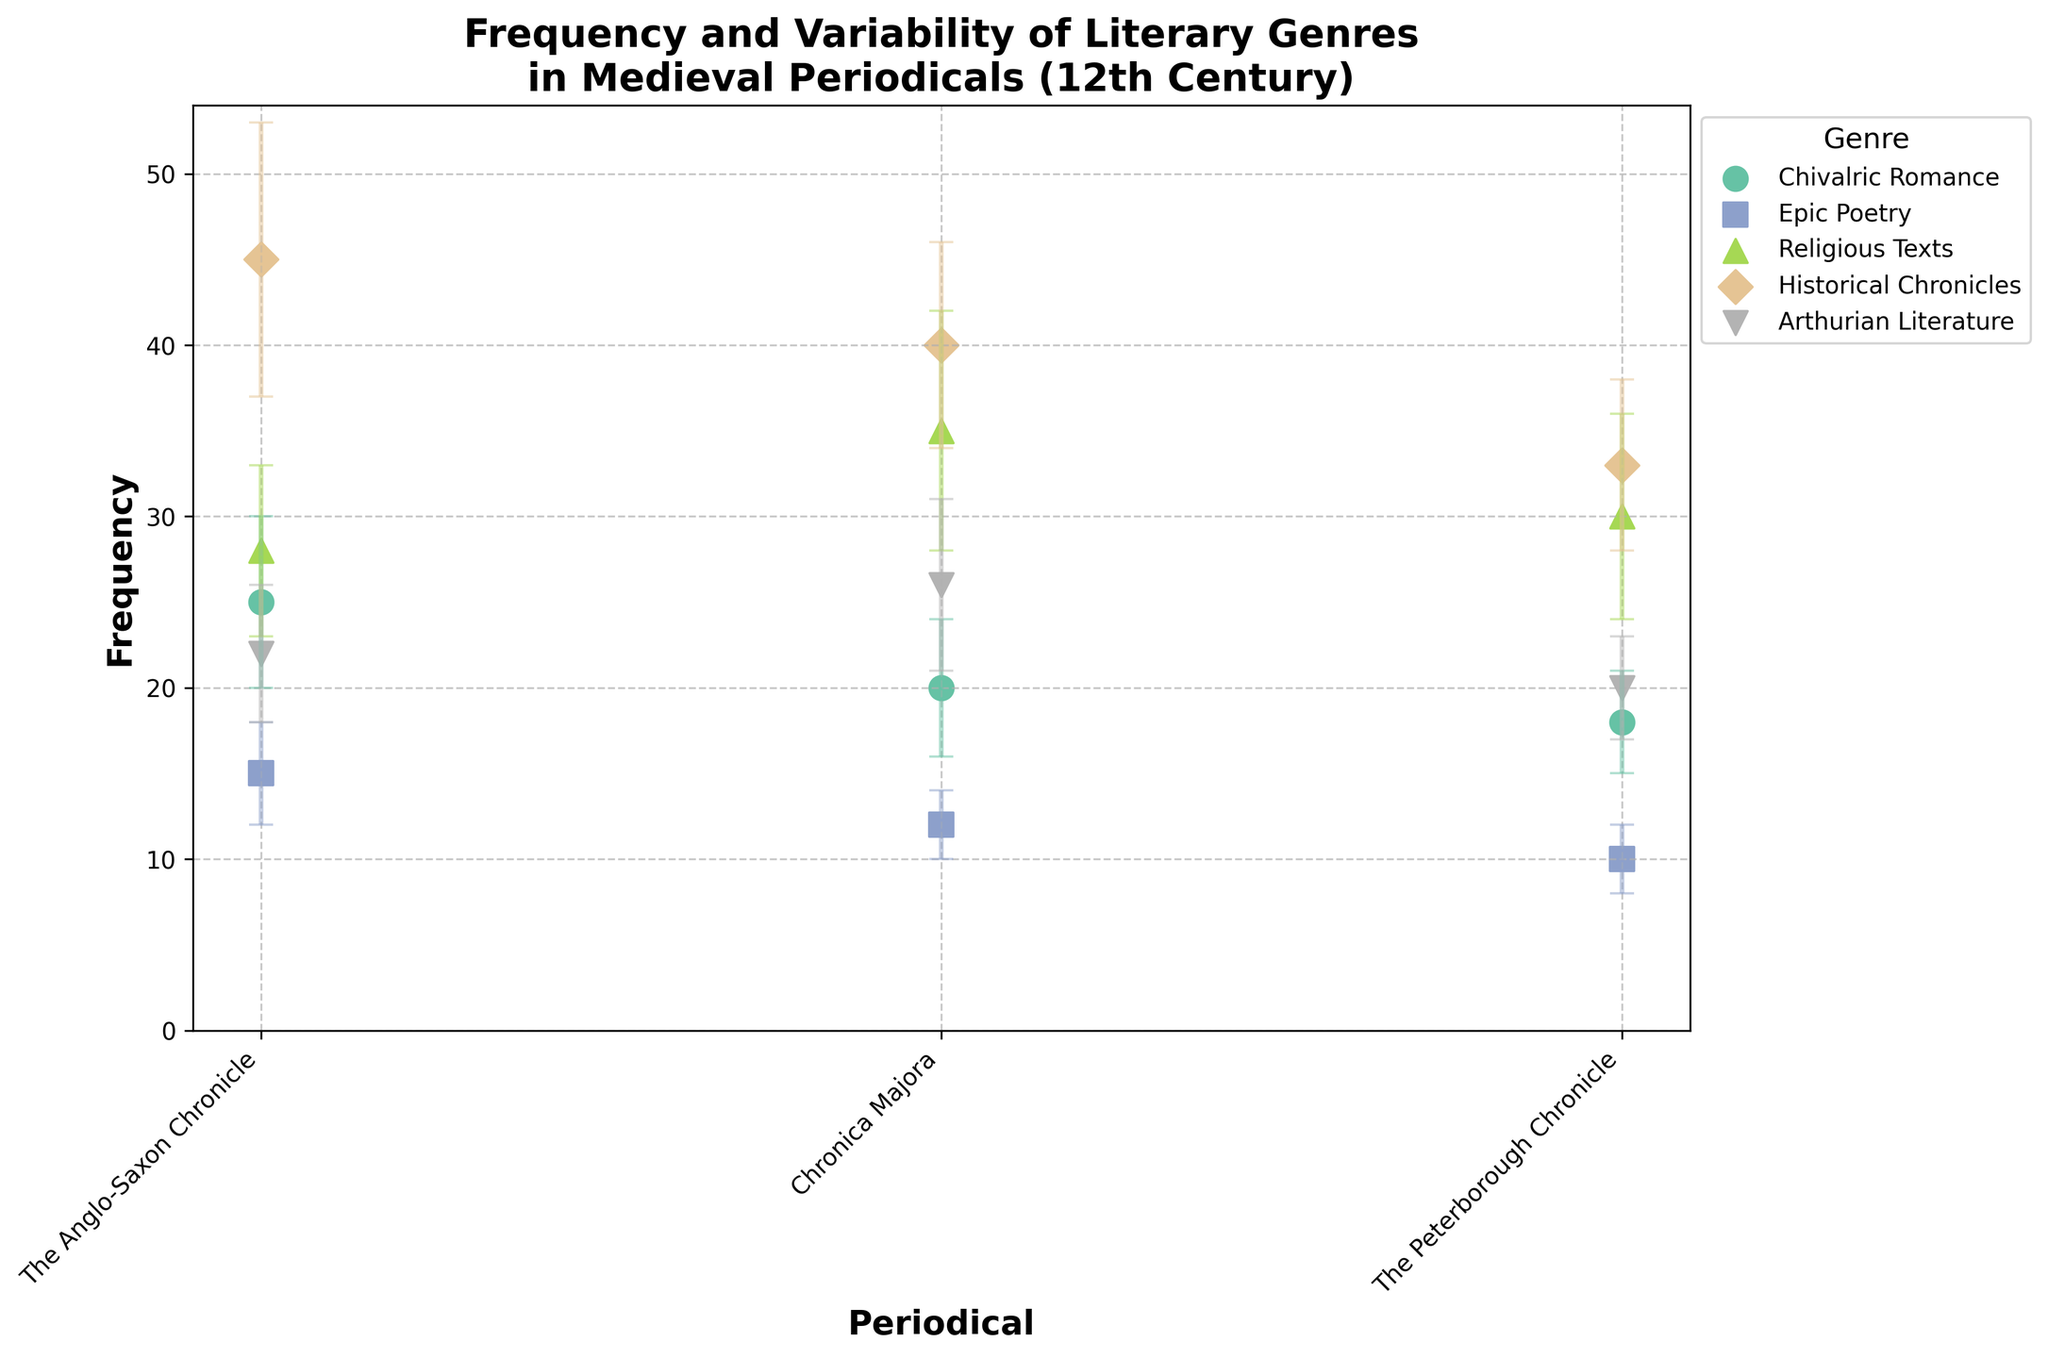What does the title of the figure indicate? The title of the figure is prominently placed at the top and describes the content of the scatter plot with error bars, indicating it is about the Frequency and Variability of Different Literary Genres in Medieval Periodicals Across the 12th Century.
Answer: Frequency and Variability of Literary Genres in Medieval Periodicals (12th Century) Which genre has the highest frequency in any periodical? Historical Chronicles in The Anglo-Saxon Chronicle has the highest frequency, indicated by the highest marker on the y-axis with the frequency of 45.
Answer: Historical Chronicles What is the frequency range for Chivalric Romance across the periodicals? To find the frequency range for Chivalric Romance, look at the highest and lowest points of this genre in different periodicals. The highest is 25 in The Anglo-Saxon Chronicle and the lowest is 18 in The Peterborough Chronicle. 25 - 18
Answer: 7 How do the error bars for Religious Texts compare to those of other genres? The error bars for Religious Texts, particularly visible in Chronica Majora, are among the largest, reflecting high variability. In Chronica Majora, the error is 7, which is higher than most other genres. This indicates greater variability in the frequency of Religious Texts.
Answer: Largest error bars, showing high variability Which periodical features the widest variability in historical chronicles? By looking at the error bars for Historical Chronicles in all periodicals, The Anglo-Saxon Chronicle has the widest error bar with an error of 8, indicating the most considerable variability.
Answer: The Anglo-Saxon Chronicle Compare the frequencies of Epic Poetry in all periodicals. In which periodical does Epic Poetry have the lowest frequency? The frequencies of Epic Poetry in different periodicals are shown as 15 in The Anglo-Saxon Chronicle, 12 in Chronica Majora, and 10 in The Peterborough Chronicle. The lowest frequency is in The Peterborough Chronicle.
Answer: The Peterborough Chronicle How many genres have their highest frequency in The Anglo-Saxon Chronicle? By scanning the plot, we can see that Chivalric Romance, Historical Chronicles, and Arthurian Literature all have their highest frequencies in The Anglo-Saxon Chronicle. Hence, there are three genres.
Answer: Three genres Which periodical generally shows the highest frequencies for most genres? Observing the scatter plot, most genres, including Historical Chronicles, Chivalric Romance, and Arthurian Literature, have one of their highest frequencies in The Anglo-Saxon Chronicle, indicating it generally shows the highest frequencies.
Answer: The Anglo-Saxon Chronicle Calculate the average frequency of Chivalric Romance across all periodicals. First collect the frequencies of Chivalric Romance: 25 (The Anglo-Saxon Chronicle), 20 (Chronica Majora), 18 (The Peterborough Chronicle). Adding them together gives 63. Dividing by the number of periodicals (3) gives an average frequency of 21.
Answer: 21 